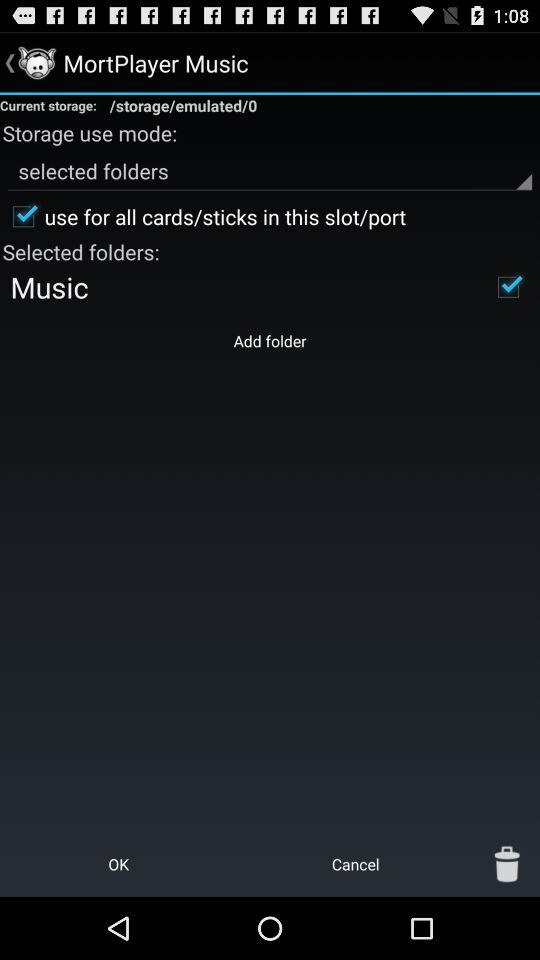What is the application name? The application name is "MortPlayer Music". 